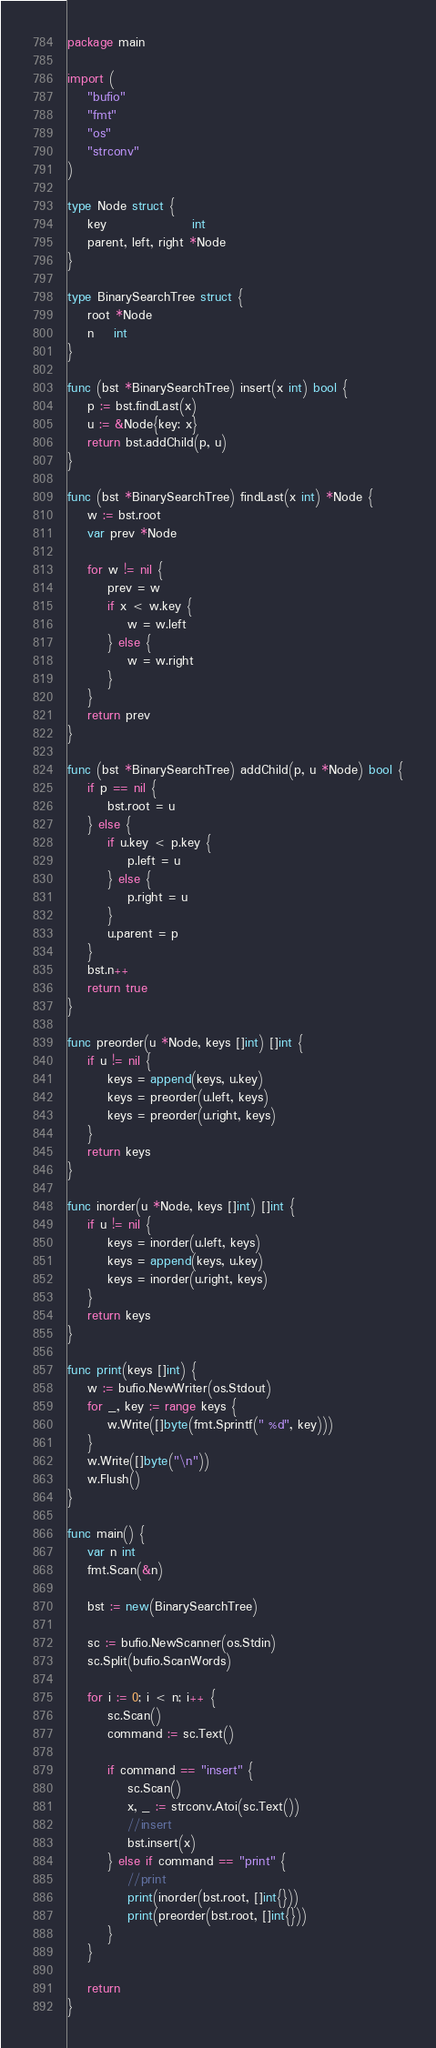Convert code to text. <code><loc_0><loc_0><loc_500><loc_500><_Go_>package main

import (
	"bufio"
	"fmt"
	"os"
	"strconv"
)

type Node struct {
	key                 int
	parent, left, right *Node
}

type BinarySearchTree struct {
	root *Node
	n    int
}

func (bst *BinarySearchTree) insert(x int) bool {
	p := bst.findLast(x)
	u := &Node{key: x}
	return bst.addChild(p, u)
}

func (bst *BinarySearchTree) findLast(x int) *Node {
	w := bst.root
	var prev *Node

	for w != nil {
		prev = w
		if x < w.key {
			w = w.left
		} else {
			w = w.right
		}
	}
	return prev
}

func (bst *BinarySearchTree) addChild(p, u *Node) bool {
	if p == nil {
		bst.root = u
	} else {
		if u.key < p.key {
			p.left = u
		} else {
			p.right = u
		}
		u.parent = p
	}
	bst.n++
	return true
}

func preorder(u *Node, keys []int) []int {
	if u != nil {
		keys = append(keys, u.key)
		keys = preorder(u.left, keys)
		keys = preorder(u.right, keys)
	}
	return keys
}

func inorder(u *Node, keys []int) []int {
	if u != nil {
		keys = inorder(u.left, keys)
		keys = append(keys, u.key)
		keys = inorder(u.right, keys)
	}
	return keys
}

func print(keys []int) {
	w := bufio.NewWriter(os.Stdout)
	for _, key := range keys {
		w.Write([]byte(fmt.Sprintf(" %d", key)))
	}
	w.Write([]byte("\n"))
	w.Flush()
}

func main() {
	var n int
	fmt.Scan(&n)

	bst := new(BinarySearchTree)

	sc := bufio.NewScanner(os.Stdin)
	sc.Split(bufio.ScanWords)

	for i := 0; i < n; i++ {
		sc.Scan()
		command := sc.Text()

		if command == "insert" {
			sc.Scan()
			x, _ := strconv.Atoi(sc.Text())
			//insert
			bst.insert(x)
		} else if command == "print" {
			//print
			print(inorder(bst.root, []int{}))
			print(preorder(bst.root, []int{}))
		}
	}

	return
}

</code> 